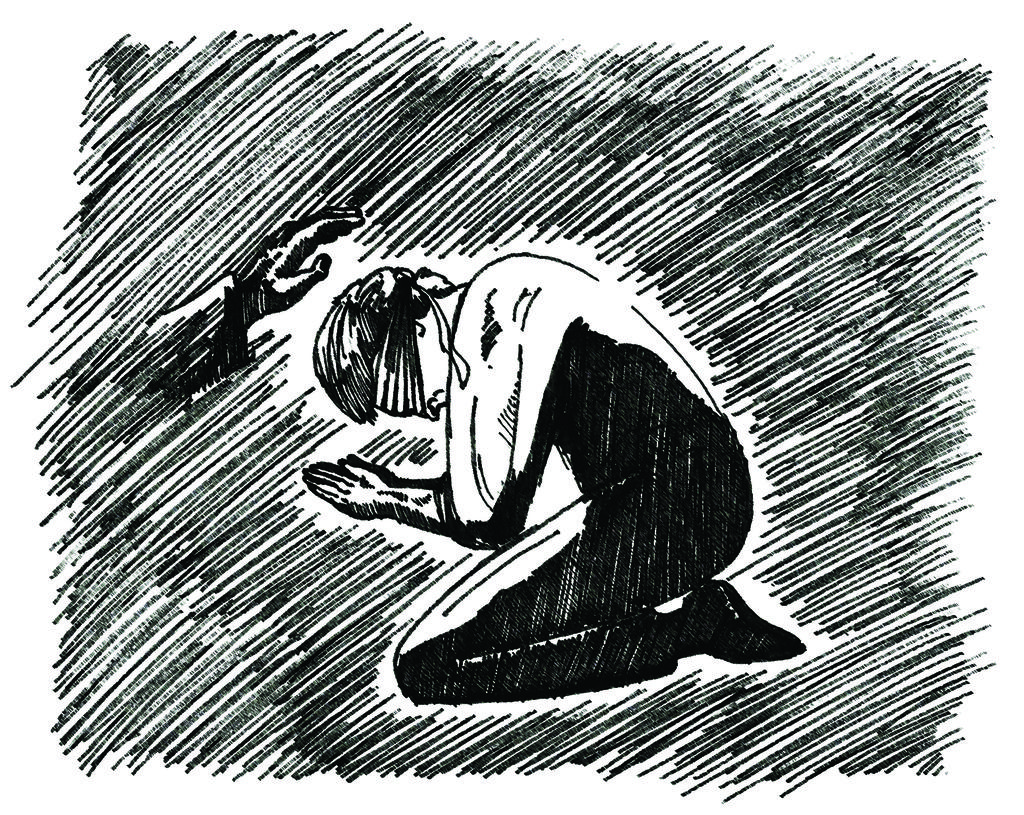What is the main action being performed by the person in the image? The person is kneeling down and praying in the image. Can you describe any other actions or gestures in the image? There is a person's hand blessing in the image. How is the image created? The image is a drawing. What type of monkey can be seen waving its wrist in the image? There is no monkey or waving wrist present in the image; it features a person praying and a blessing hand. 